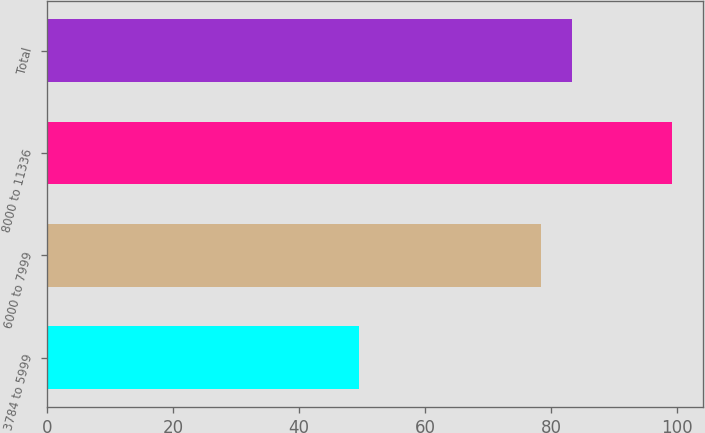Convert chart. <chart><loc_0><loc_0><loc_500><loc_500><bar_chart><fcel>3784 to 5999<fcel>6000 to 7999<fcel>8000 to 11336<fcel>Total<nl><fcel>49.45<fcel>78.34<fcel>99.12<fcel>83.31<nl></chart> 